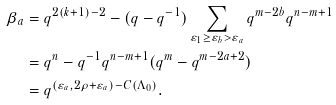<formula> <loc_0><loc_0><loc_500><loc_500>\beta _ { a } & = q ^ { 2 ( k + 1 ) - 2 } - ( q - q ^ { - 1 } ) \sum _ { \varepsilon _ { 1 } \geq \varepsilon _ { b } > \varepsilon _ { a } } q ^ { m - 2 b } q ^ { n - m + 1 } \\ & = q ^ { n } - q ^ { - 1 } q ^ { n - m + 1 } ( q ^ { m } - q ^ { m - 2 a + 2 } ) \\ & = q ^ { ( \varepsilon _ { a } , 2 \rho + \varepsilon _ { a } ) - C ( \Lambda _ { 0 } ) } .</formula> 